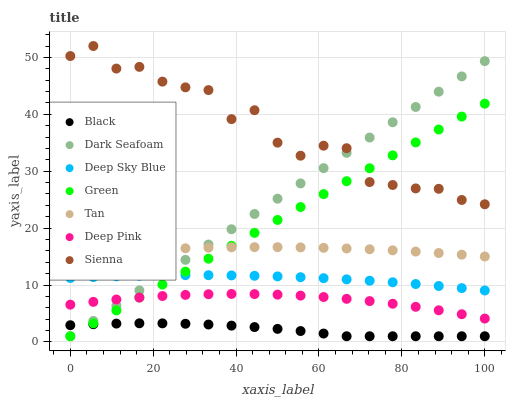Does Black have the minimum area under the curve?
Answer yes or no. Yes. Does Sienna have the maximum area under the curve?
Answer yes or no. Yes. Does Dark Seafoam have the minimum area under the curve?
Answer yes or no. No. Does Dark Seafoam have the maximum area under the curve?
Answer yes or no. No. Is Green the smoothest?
Answer yes or no. Yes. Is Sienna the roughest?
Answer yes or no. Yes. Is Dark Seafoam the smoothest?
Answer yes or no. No. Is Dark Seafoam the roughest?
Answer yes or no. No. Does Dark Seafoam have the lowest value?
Answer yes or no. Yes. Does Sienna have the lowest value?
Answer yes or no. No. Does Sienna have the highest value?
Answer yes or no. Yes. Does Dark Seafoam have the highest value?
Answer yes or no. No. Is Deep Pink less than Tan?
Answer yes or no. Yes. Is Sienna greater than Deep Sky Blue?
Answer yes or no. Yes. Does Dark Seafoam intersect Green?
Answer yes or no. Yes. Is Dark Seafoam less than Green?
Answer yes or no. No. Is Dark Seafoam greater than Green?
Answer yes or no. No. Does Deep Pink intersect Tan?
Answer yes or no. No. 